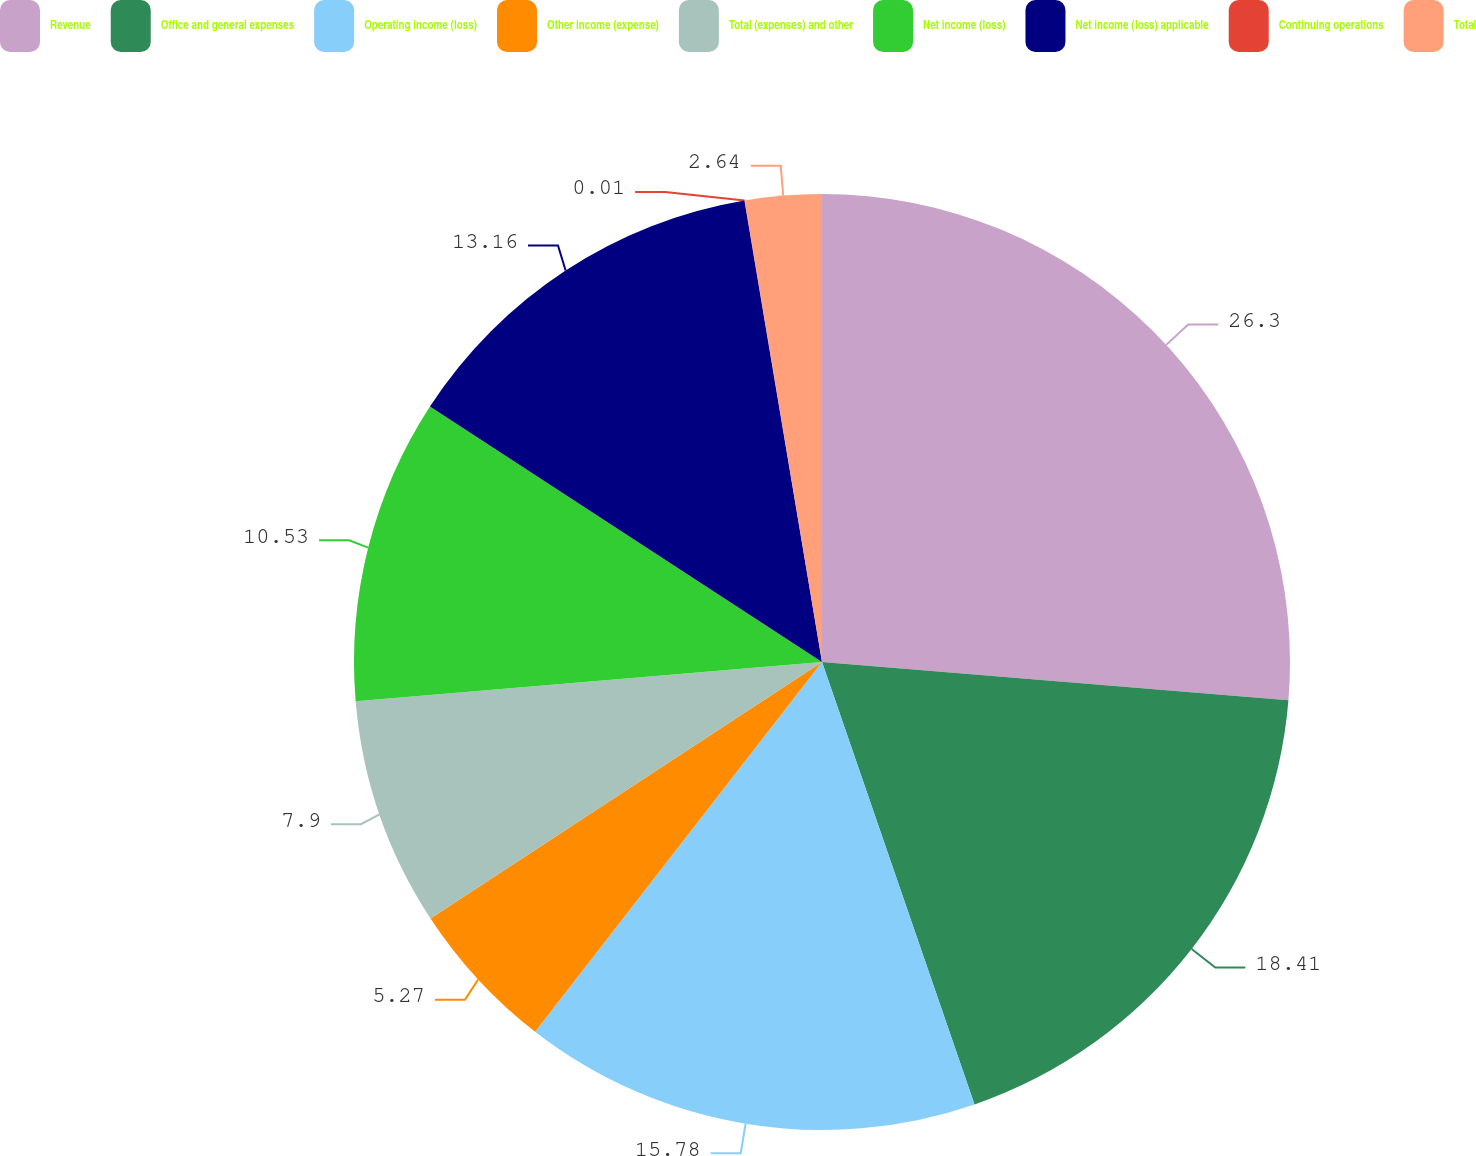Convert chart to OTSL. <chart><loc_0><loc_0><loc_500><loc_500><pie_chart><fcel>Revenue<fcel>Office and general expenses<fcel>Operating income (loss)<fcel>Other income (expense)<fcel>Total (expenses) and other<fcel>Net income (loss)<fcel>Net income (loss) applicable<fcel>Continuing operations<fcel>Total<nl><fcel>26.31%<fcel>18.42%<fcel>15.79%<fcel>5.27%<fcel>7.9%<fcel>10.53%<fcel>13.16%<fcel>0.01%<fcel>2.64%<nl></chart> 